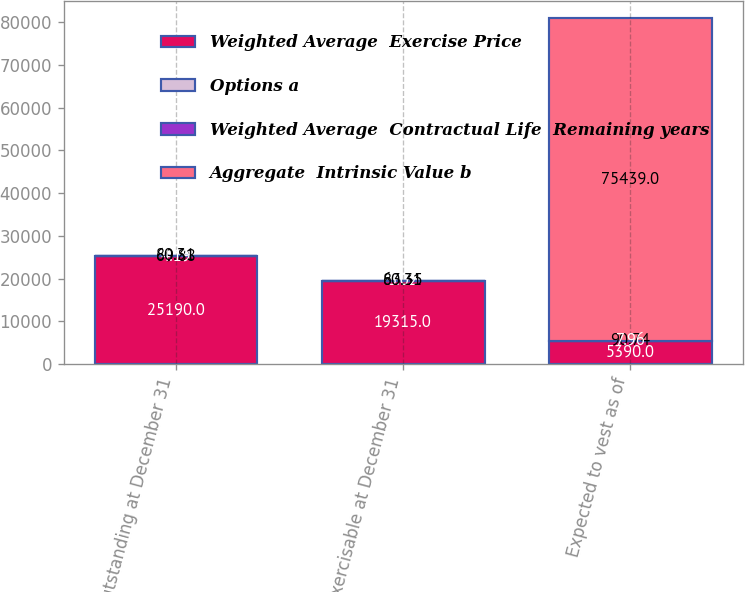Convert chart to OTSL. <chart><loc_0><loc_0><loc_500><loc_500><stacked_bar_chart><ecel><fcel>Outstanding at December 31<fcel>Exercisable at December 31<fcel>Expected to vest as of<nl><fcel>Weighted Average  Exercise Price<fcel>25190<fcel>19315<fcel>5390<nl><fcel>Options a<fcel>69.88<fcel>63.35<fcel>90.74<nl><fcel>Weighted Average  Contractual Life  Remaining years<fcel>4.19<fcel>3.02<fcel>7.96<nl><fcel>Aggregate  Intrinsic Value b<fcel>80.31<fcel>80.31<fcel>75439<nl></chart> 